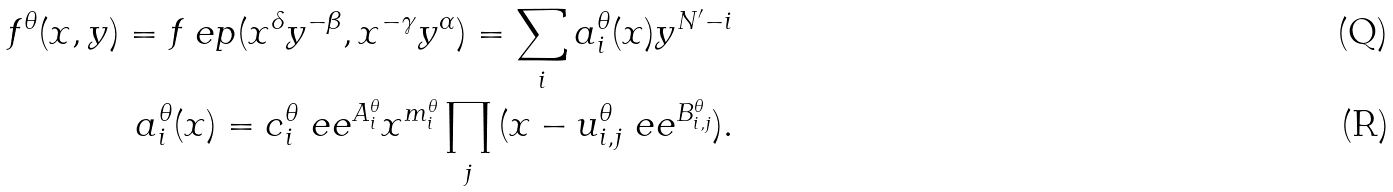<formula> <loc_0><loc_0><loc_500><loc_500>f ^ { \theta } ( x , y ) = f _ { \ } e p ( x ^ { \delta } y ^ { - \beta } , x ^ { - \gamma } y ^ { \alpha } ) = \sum _ { i } { a ^ { \theta } _ { i } ( x ) y ^ { N ^ { \prime } - i } } \\ a ^ { \theta } _ { i } ( x ) = c ^ { \theta } _ { i } \ e e ^ { A ^ { \theta } _ { i } } x ^ { m ^ { \theta } _ { i } } \prod _ { j } { ( x - u ^ { \theta } _ { i , j } \ e e ^ { B ^ { \theta } _ { i , j } } ) } .</formula> 